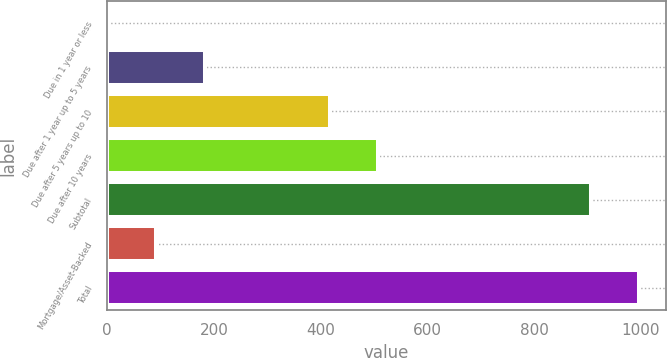Convert chart to OTSL. <chart><loc_0><loc_0><loc_500><loc_500><bar_chart><fcel>Due in 1 year or less<fcel>Due after 1 year up to 5 years<fcel>Due after 5 years up to 10<fcel>Due after 10 years<fcel>Subtotal<fcel>Mortgage/Asset-Backed<fcel>Total<nl><fcel>1<fcel>183.46<fcel>417.1<fcel>508.33<fcel>906.4<fcel>92.23<fcel>997.63<nl></chart> 